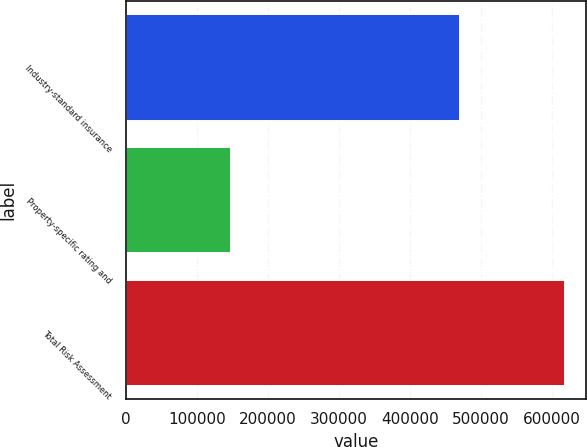Convert chart to OTSL. <chart><loc_0><loc_0><loc_500><loc_500><bar_chart><fcel>Industry-standard insurance<fcel>Property-specific rating and<fcel>Total Risk Assessment<nl><fcel>471130<fcel>147146<fcel>618276<nl></chart> 